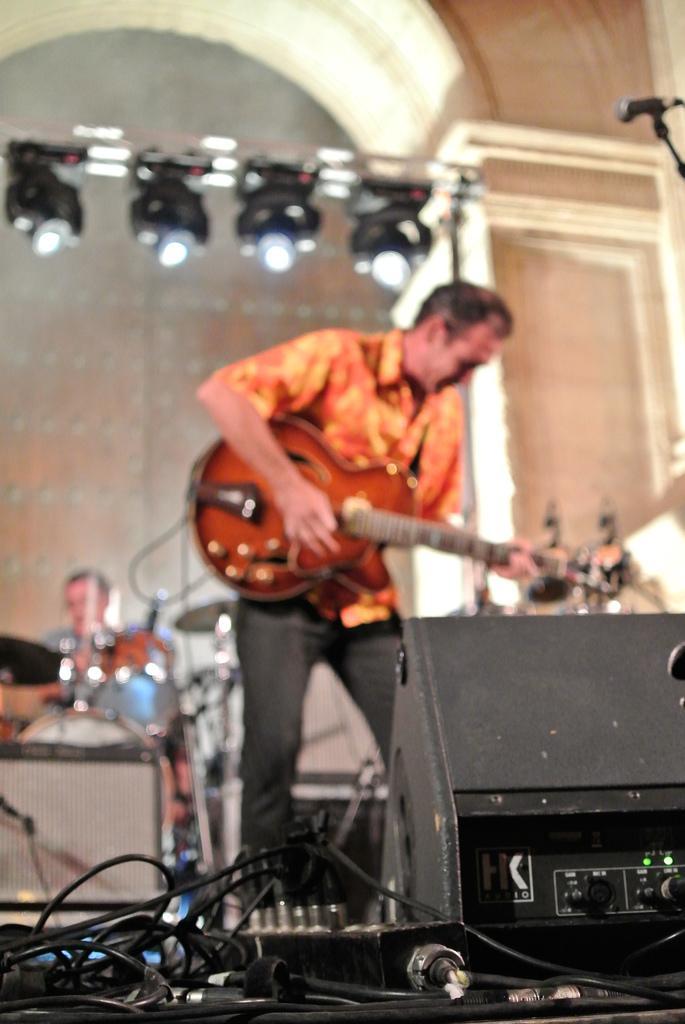Can you describe this image briefly? This image is taken on a stage. There are two persons on the stage. In the middle of the image a person standing holding a guitar and playing a music. At the back a man sitting on a chair and playing drums. At the bottom of the image there are many wires. At the top of the image there are few lights and an arch. 